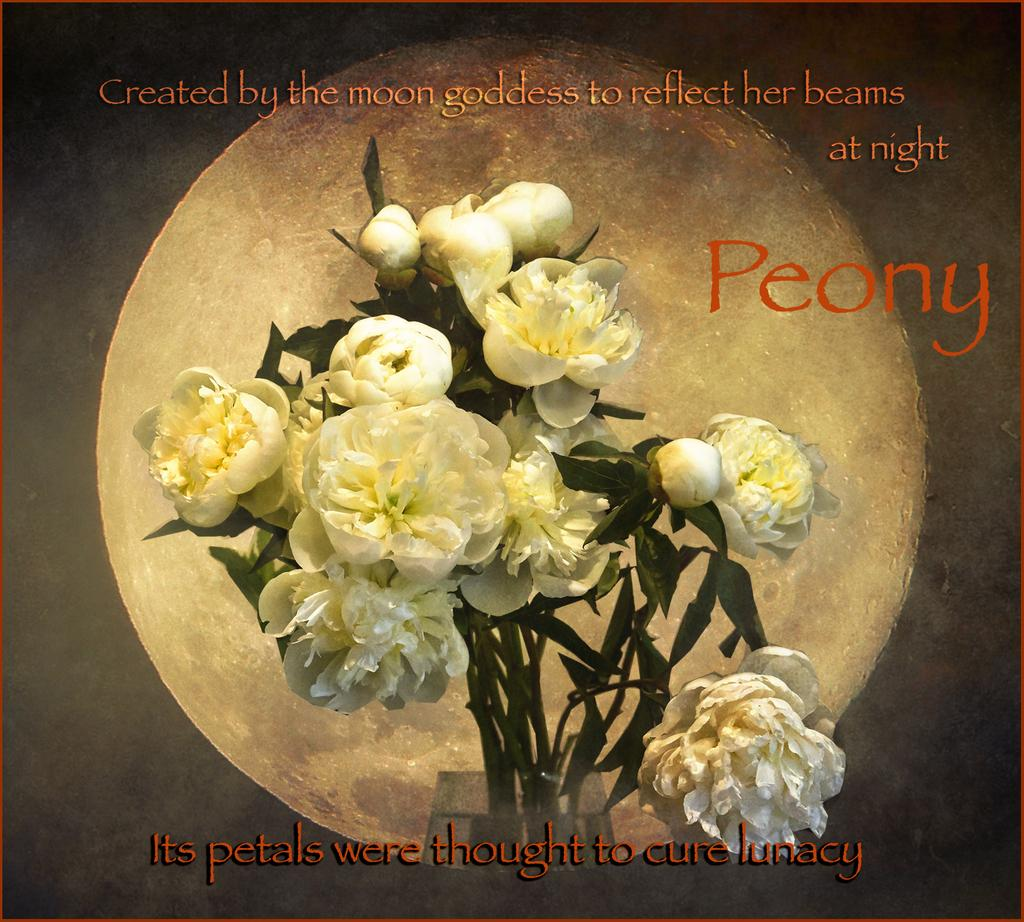What is the main object in the center of the image? There is a flower vase in the center of the image. What can be seen in the background of the image? The background of the image features the moon. Are there any words or letters in the image? Yes, there is text at the top and bottom of the image. Has the image been altered in any way? Yes, the image has been edited. How many deer are visible in the image? There are no deer present in the image. What type of waste is being disposed of in the image? There is no waste being disposed of in the image. 